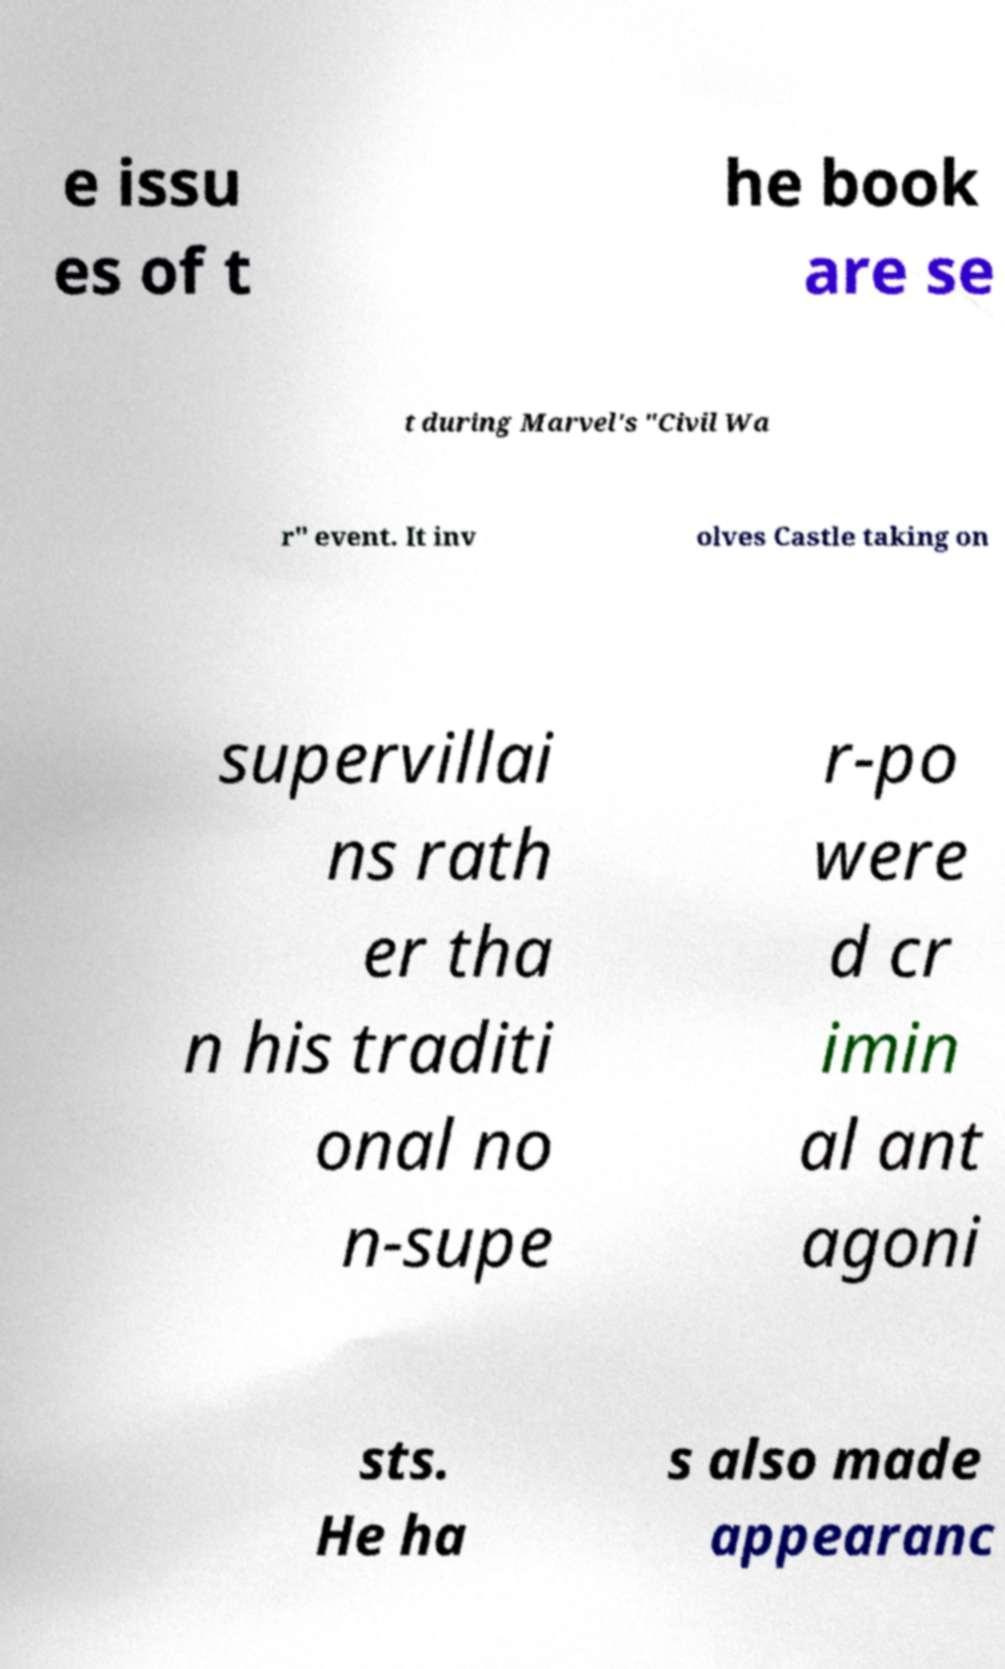Please identify and transcribe the text found in this image. e issu es of t he book are se t during Marvel's "Civil Wa r" event. It inv olves Castle taking on supervillai ns rath er tha n his traditi onal no n-supe r-po were d cr imin al ant agoni sts. He ha s also made appearanc 